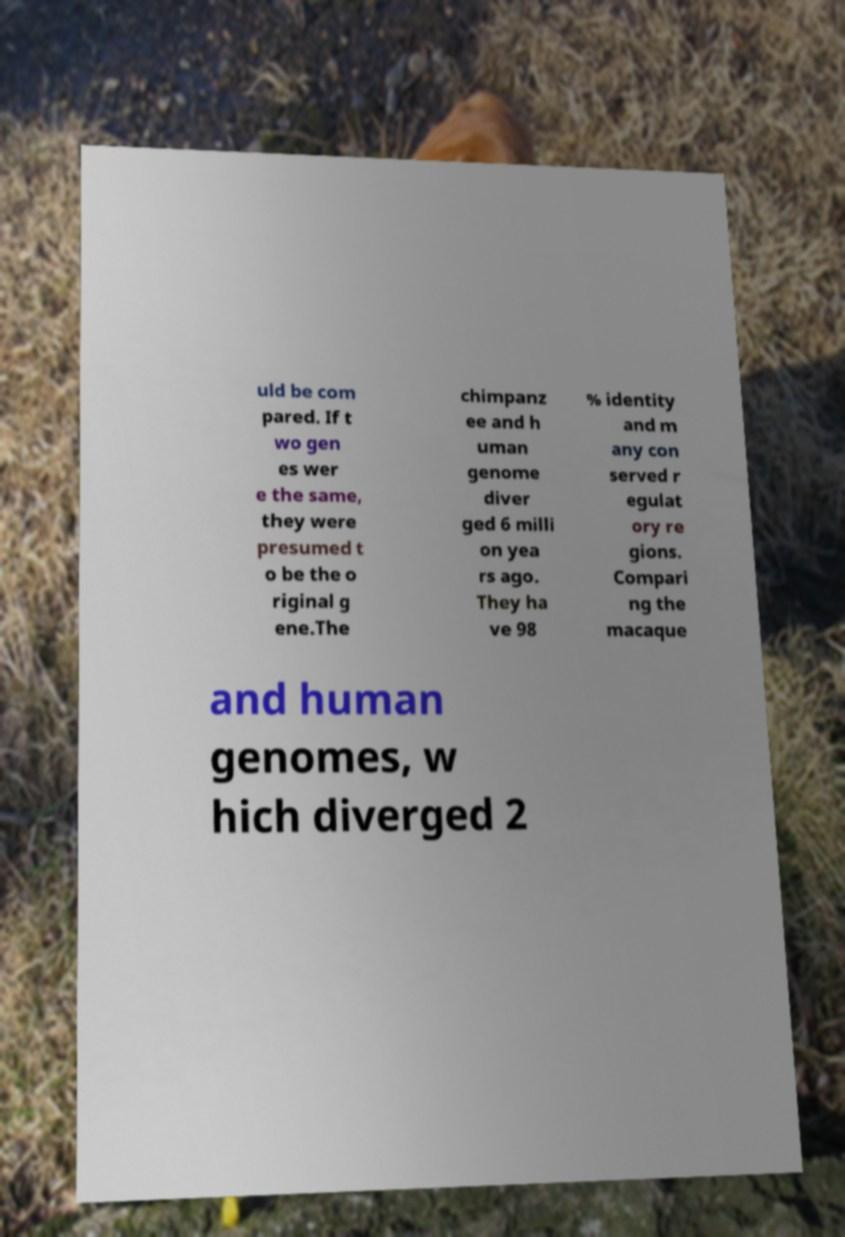Please read and relay the text visible in this image. What does it say? uld be com pared. If t wo gen es wer e the same, they were presumed t o be the o riginal g ene.The chimpanz ee and h uman genome diver ged 6 milli on yea rs ago. They ha ve 98 % identity and m any con served r egulat ory re gions. Compari ng the macaque and human genomes, w hich diverged 2 